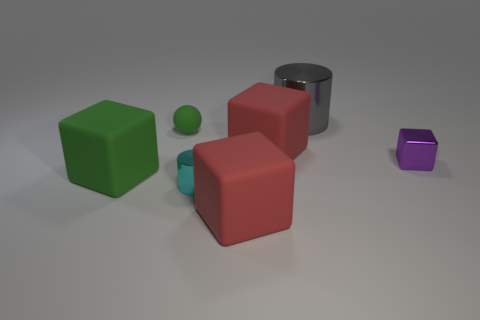Subtract all blue spheres. Subtract all red cylinders. How many spheres are left? 1 Subtract all gray balls. How many green cubes are left? 1 Add 4 small things. How many large reds exist? 0 Subtract all red objects. Subtract all purple shiny blocks. How many objects are left? 4 Add 4 big cylinders. How many big cylinders are left? 5 Add 3 large yellow rubber things. How many large yellow rubber things exist? 3 Add 3 small cyan rubber balls. How many objects exist? 10 Subtract all gray cylinders. How many cylinders are left? 1 Subtract all metallic cubes. How many cubes are left? 3 Subtract 0 blue cylinders. How many objects are left? 7 